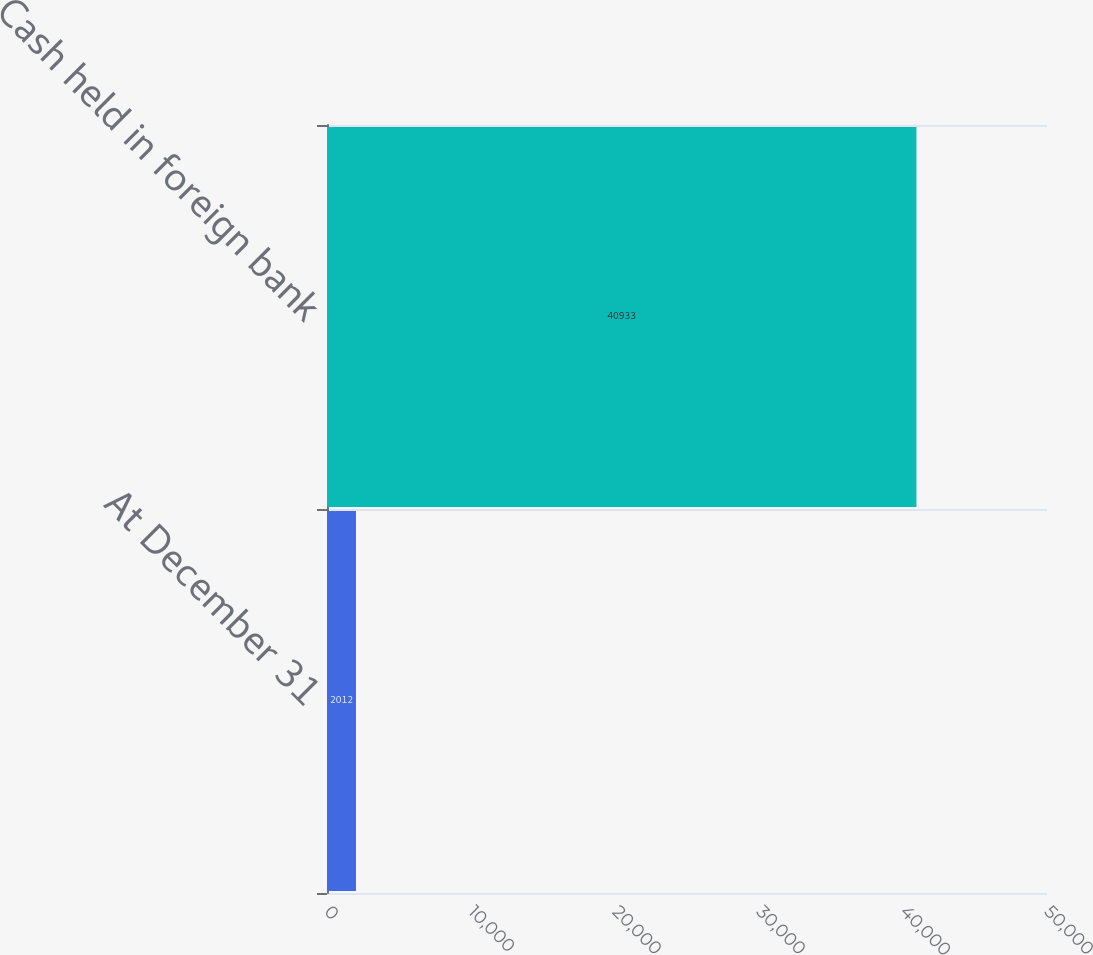Convert chart. <chart><loc_0><loc_0><loc_500><loc_500><bar_chart><fcel>At December 31<fcel>Cash held in foreign bank<nl><fcel>2012<fcel>40933<nl></chart> 